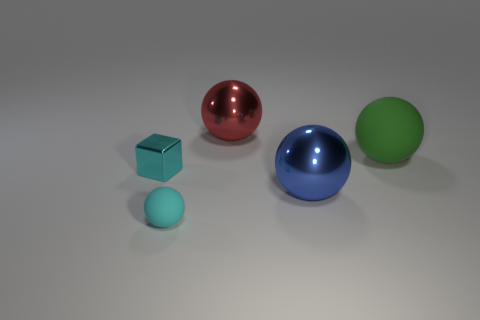How many cyan objects are either tiny shiny cubes or tiny metal cylinders?
Keep it short and to the point. 1. What is the shape of the big matte thing?
Make the answer very short. Sphere. How many other objects are the same shape as the big green object?
Provide a succinct answer. 3. What color is the sphere that is on the left side of the red metallic object?
Offer a very short reply. Cyan. Do the blue sphere and the green ball have the same material?
Provide a short and direct response. No. What number of objects are small cyan rubber spheres or cyan metal blocks that are left of the large blue ball?
Keep it short and to the point. 2. There is a ball that is the same color as the small shiny thing; what is its size?
Your response must be concise. Small. There is a shiny object that is on the left side of the big red thing; what shape is it?
Your response must be concise. Cube. There is a matte ball in front of the small metal block; is its color the same as the block?
Provide a short and direct response. Yes. What material is the other tiny object that is the same color as the small matte object?
Offer a terse response. Metal. 